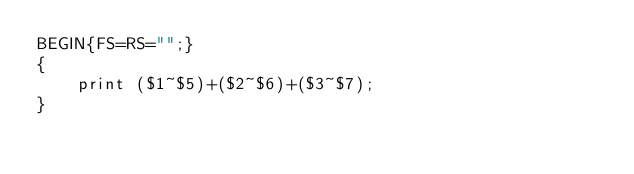<code> <loc_0><loc_0><loc_500><loc_500><_Awk_>BEGIN{FS=RS="";}
{
    print ($1~$5)+($2~$6)+($3~$7);
}</code> 